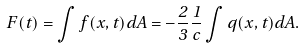Convert formula to latex. <formula><loc_0><loc_0><loc_500><loc_500>\vec { F } ( t ) = \int \vec { f } ( \vec { x } , t ) d A = - \frac { 2 } { 3 } \frac { 1 } { c } \int q ( \vec { x } , t ) \vec { d A } .</formula> 